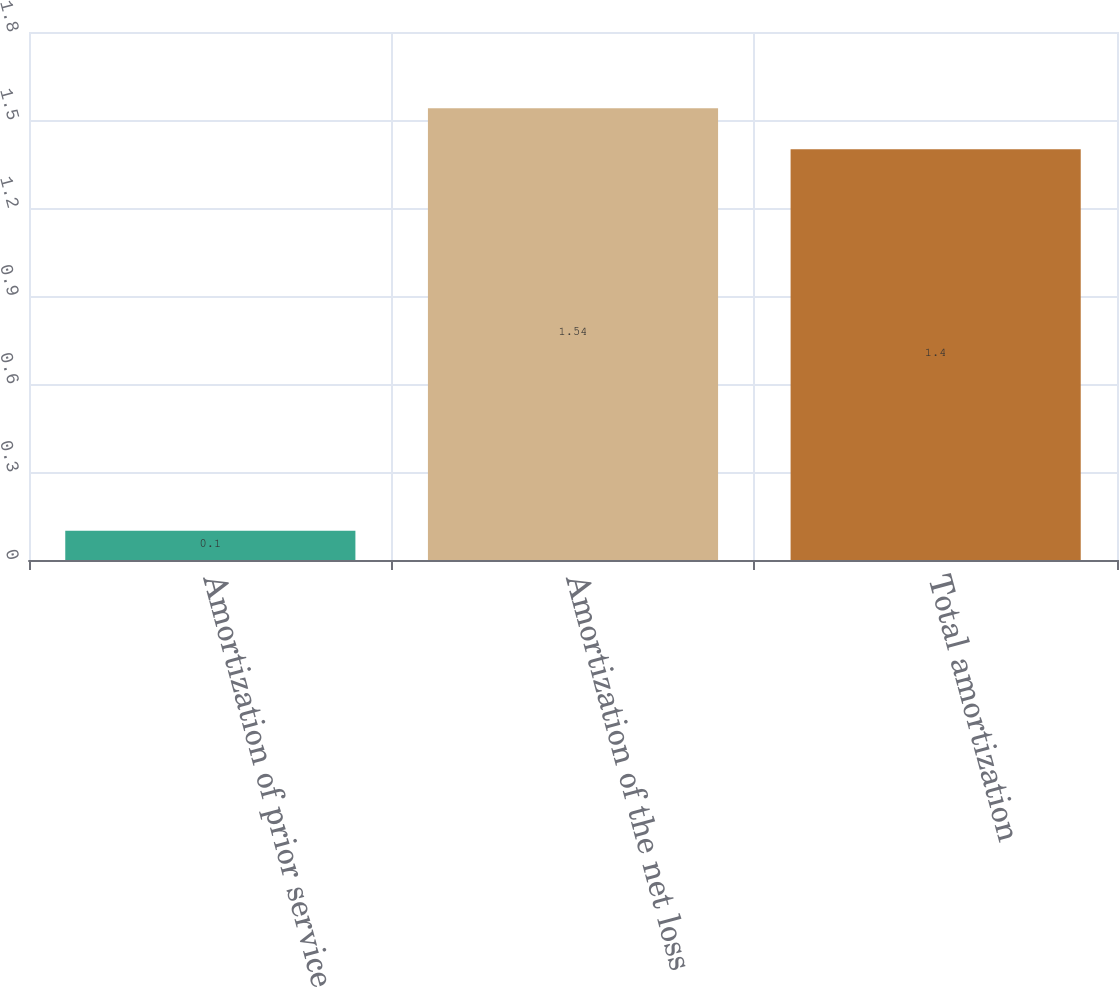Convert chart to OTSL. <chart><loc_0><loc_0><loc_500><loc_500><bar_chart><fcel>Amortization of prior service<fcel>Amortization of the net loss<fcel>Total amortization<nl><fcel>0.1<fcel>1.54<fcel>1.4<nl></chart> 